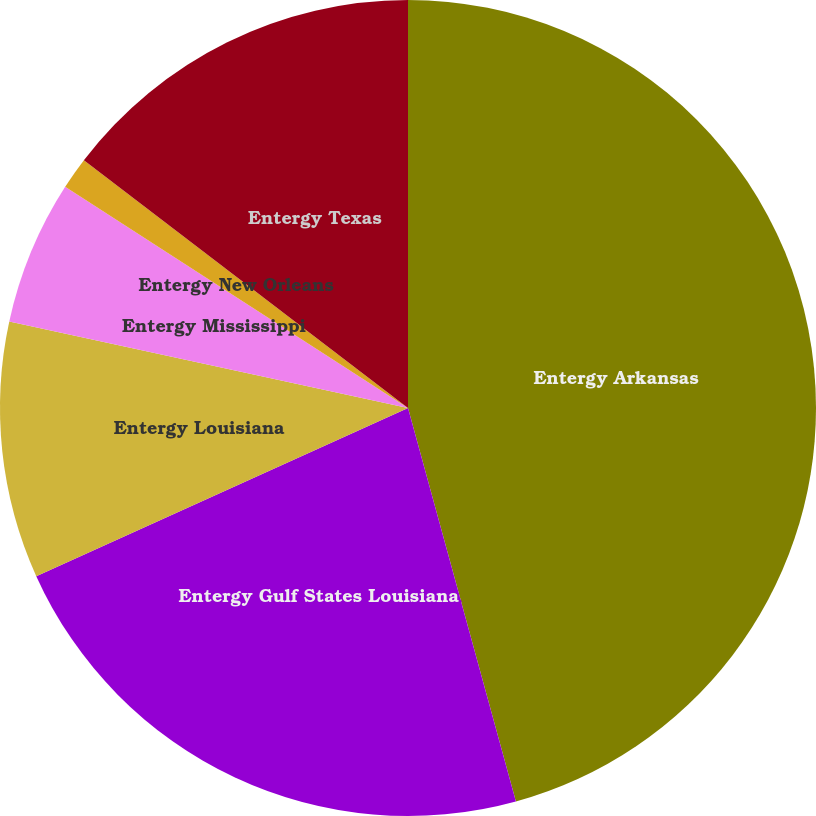Convert chart. <chart><loc_0><loc_0><loc_500><loc_500><pie_chart><fcel>Entergy Arkansas<fcel>Entergy Gulf States Louisiana<fcel>Entergy Louisiana<fcel>Entergy Mississippi<fcel>Entergy New Orleans<fcel>Entergy Texas<nl><fcel>45.74%<fcel>22.5%<fcel>10.16%<fcel>5.72%<fcel>1.27%<fcel>14.61%<nl></chart> 